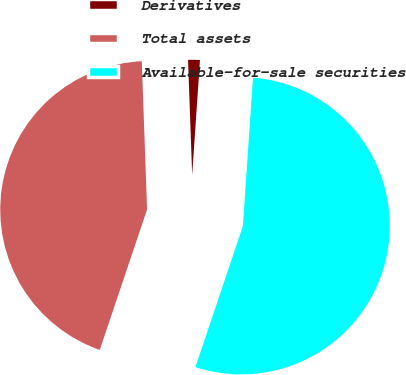Convert chart. <chart><loc_0><loc_0><loc_500><loc_500><pie_chart><fcel>Derivatives<fcel>Total assets<fcel>Available-for-sale securities<nl><fcel>1.65%<fcel>44.26%<fcel>54.09%<nl></chart> 